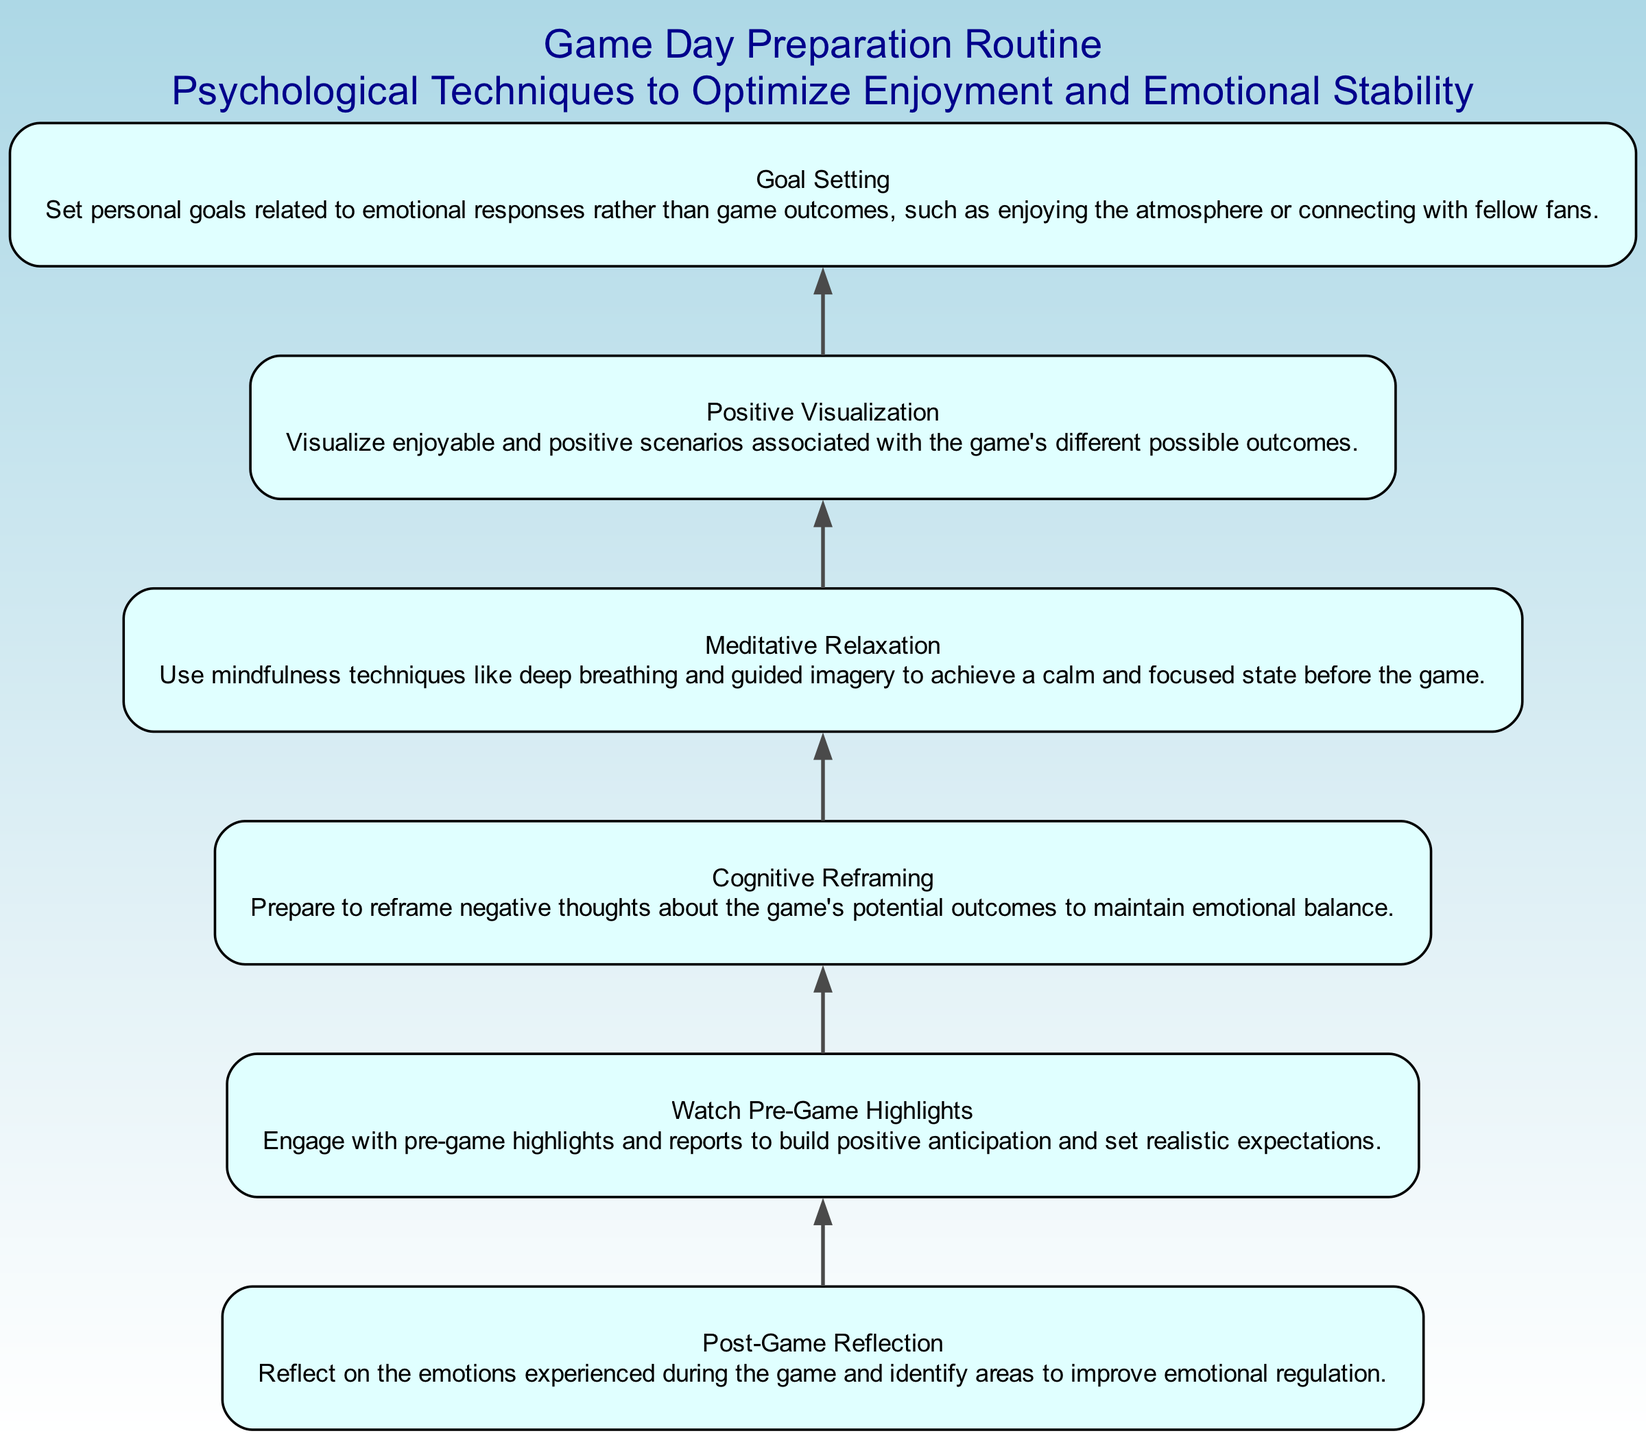What is the first step in the Game Day Preparation Routine? The first step in the routine, as seen at the bottom of the flow chart, is "Goal Setting". This is the starting point of the preparation process for optimizing enjoyment and emotional stability on game day.
Answer: Goal Setting How many nodes are present in the diagram? By counting each distinct step listed in the flow chart, we find there are a total of six nodes. These nodes represent different psychological techniques.
Answer: Six What is the last node in the flow chart? The last node can be identified at the top of the flow chart, which shows "Post-Game Reflection". This is the concluding step in the preparation routine.
Answer: Post-Game Reflection Which node comes after "Positive Visualization"? Examining the sequence of nodes in the flow chart, the node that follows "Positive Visualization" is "Cognitive Reframing". The flow indicates the order of operations from bottom to top.
Answer: Cognitive Reframing How does "Meditative Relaxation" relate to "Post-Game Reflection"? Analyzing the relationship between the nodes, "Meditative Relaxation", which is lower, marks a necessary step that helps regulate emotions leading into "Post-Game Reflection", which involves reflecting on those emotions afterward. Thus, it denotes a preparatory phase for post-game evaluation.
Answer: Preparatory step What type of goals should be set according to the routine? From the "Goal Setting" node, we see that the focus should be on personal goals related to emotional responses, rather than on the outcomes of the game itself. This emphasizes emotional well-being over game success.
Answer: Emotional responses In what order do the techniques flow from the bottom to the top? By tracing the nodes from the bottom of the flow chart to the top, the order of techniques is: Goal Setting, Meditative Relaxation, Positive Visualization, Cognitive Reframing, Watch Pre-Game Highlights, and finally Post-Game Reflection. This sequence outlines the structured process intended for optimum emotional management.
Answer: Goal Setting, Meditative Relaxation, Positive Visualization, Cognitive Reframing, Watch Pre-Game Highlights, Post-Game Reflection What emotion regulation technique is suggested before the game? The diagram specifically advises using "Meditative Relaxation" as a technique before the game, suggesting its role in achieving a calm and focused state. This step is crucial for managing pre-game anxiety.
Answer: Meditative Relaxation 